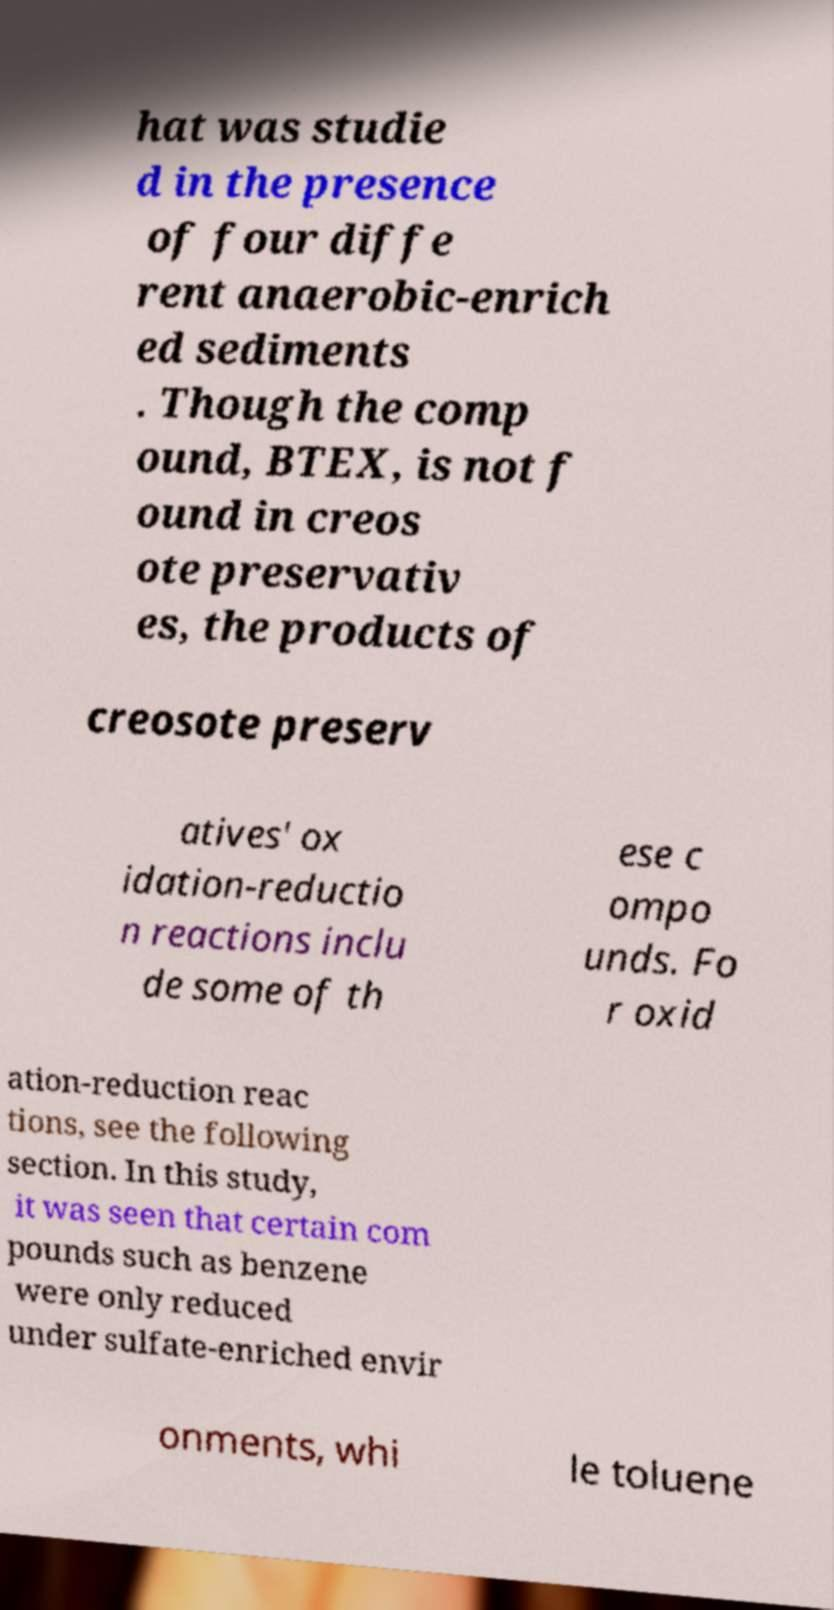There's text embedded in this image that I need extracted. Can you transcribe it verbatim? hat was studie d in the presence of four diffe rent anaerobic-enrich ed sediments . Though the comp ound, BTEX, is not f ound in creos ote preservativ es, the products of creosote preserv atives' ox idation-reductio n reactions inclu de some of th ese c ompo unds. Fo r oxid ation-reduction reac tions, see the following section. In this study, it was seen that certain com pounds such as benzene were only reduced under sulfate-enriched envir onments, whi le toluene 